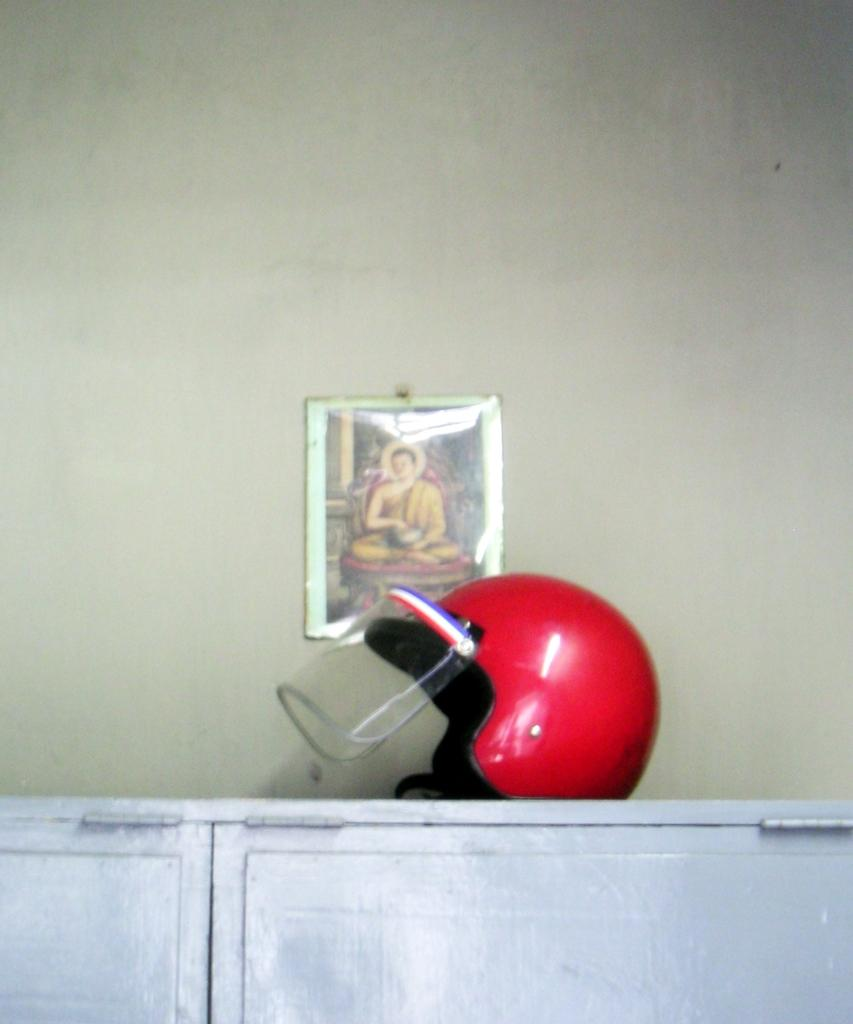What type of helmet is visible in the image? There is a red color helmet in the image. Where is the helmet placed in the image? The helmet is kept on a table. What other object can be seen in the image besides the helmet? There is a photo frame in the image. Where is the photo frame located in the image? The photo frame is on a wall. What is the color of the wall where the photo frame is located? The wall is in white color. What type of copper drain can be seen in the image? There is no copper drain present in the image. 